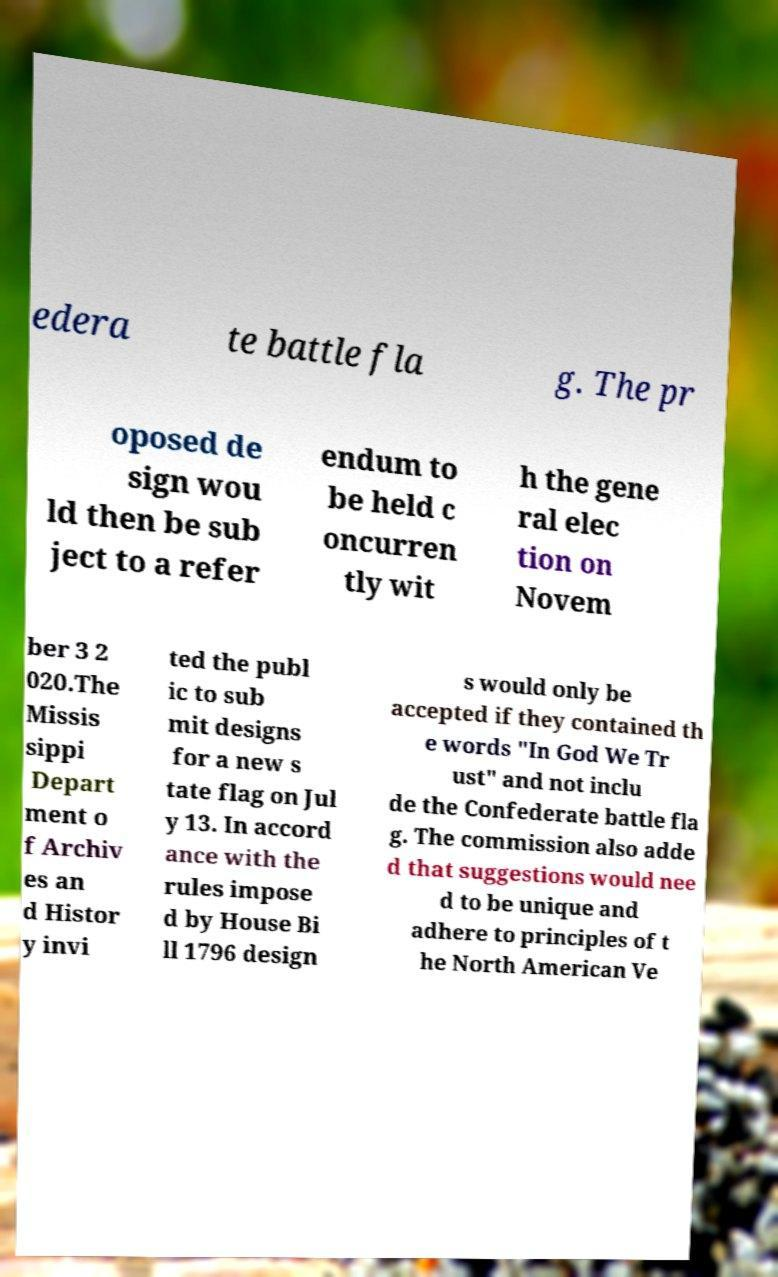What messages or text are displayed in this image? I need them in a readable, typed format. edera te battle fla g. The pr oposed de sign wou ld then be sub ject to a refer endum to be held c oncurren tly wit h the gene ral elec tion on Novem ber 3 2 020.The Missis sippi Depart ment o f Archiv es an d Histor y invi ted the publ ic to sub mit designs for a new s tate flag on Jul y 13. In accord ance with the rules impose d by House Bi ll 1796 design s would only be accepted if they contained th e words "In God We Tr ust" and not inclu de the Confederate battle fla g. The commission also adde d that suggestions would nee d to be unique and adhere to principles of t he North American Ve 